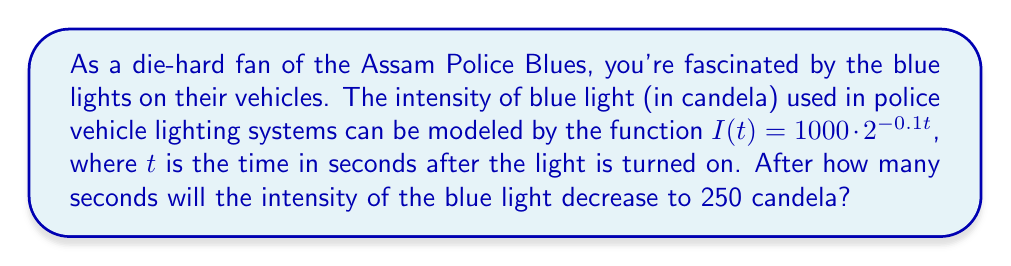Help me with this question. Let's approach this step-by-step using logarithms:

1) We start with the given function: $I(t) = 1000 \cdot 2^{-0.1t}$

2) We want to find $t$ when $I(t) = 250$. So, let's set up the equation:
   
   $250 = 1000 \cdot 2^{-0.1t}$

3) Divide both sides by 1000:
   
   $\frac{1}{4} = 2^{-0.1t}$

4) Now, we can apply logarithms to both sides. Let's use log base 2:
   
   $\log_2(\frac{1}{4}) = \log_2(2^{-0.1t})$

5) Using the logarithm property $\log_a(x^n) = n\log_a(x)$, the right side simplifies to:
   
   $\log_2(\frac{1}{4}) = -0.1t$

6) We know that $\log_2(\frac{1}{4}) = \log_2(2^{-2}) = -2$, so:
   
   $-2 = -0.1t$

7) Solve for $t$ by dividing both sides by -0.1:
   
   $t = \frac{-2}{-0.1} = 20$

Therefore, the intensity will decrease to 250 candela after 20 seconds.
Answer: 20 seconds 